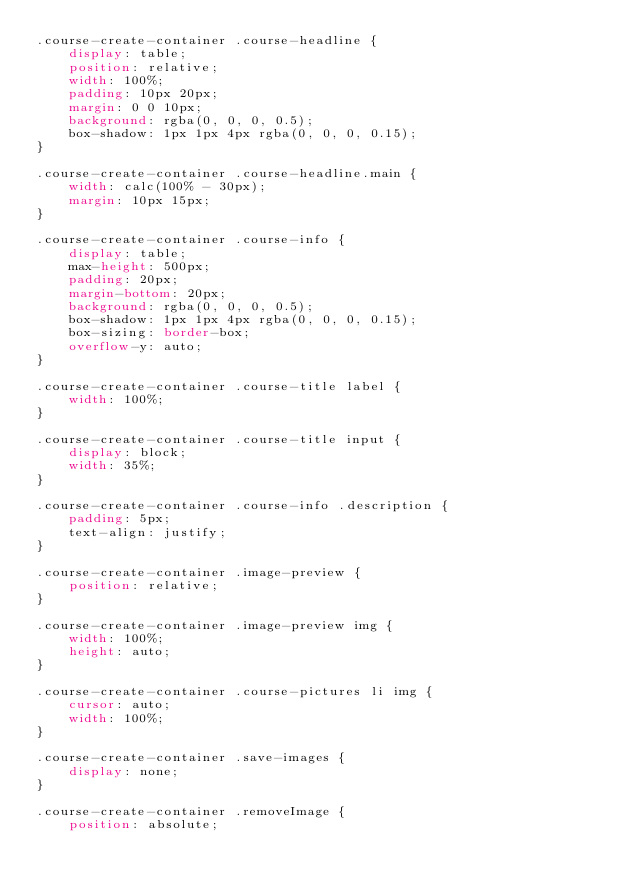Convert code to text. <code><loc_0><loc_0><loc_500><loc_500><_CSS_>.course-create-container .course-headline {
    display: table;
    position: relative;
    width: 100%;
    padding: 10px 20px;
    margin: 0 0 10px;
    background: rgba(0, 0, 0, 0.5);
    box-shadow: 1px 1px 4px rgba(0, 0, 0, 0.15);
}

.course-create-container .course-headline.main {
    width: calc(100% - 30px);
    margin: 10px 15px;
}

.course-create-container .course-info {
    display: table;
    max-height: 500px;
    padding: 20px;
    margin-bottom: 20px;
    background: rgba(0, 0, 0, 0.5);
    box-shadow: 1px 1px 4px rgba(0, 0, 0, 0.15);
    box-sizing: border-box;
    overflow-y: auto;
}

.course-create-container .course-title label {
    width: 100%;
}

.course-create-container .course-title input {
    display: block;
    width: 35%;
}

.course-create-container .course-info .description {
    padding: 5px;
    text-align: justify;
}

.course-create-container .image-preview {
    position: relative;
}

.course-create-container .image-preview img {
    width: 100%;
    height: auto;
}

.course-create-container .course-pictures li img {
    cursor: auto;
    width: 100%;
}

.course-create-container .save-images {
    display: none;
}

.course-create-container .removeImage {
    position: absolute;</code> 